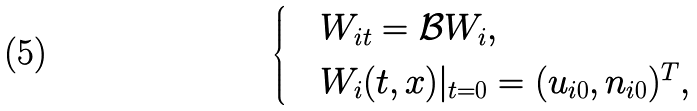<formula> <loc_0><loc_0><loc_500><loc_500>\begin{cases} & W _ { i t } = \mathcal { B } W _ { i } , \\ & W _ { i } ( t , x ) | _ { t = 0 } = ( u _ { i 0 } , n _ { i 0 } ) ^ { T } , \end{cases}</formula> 